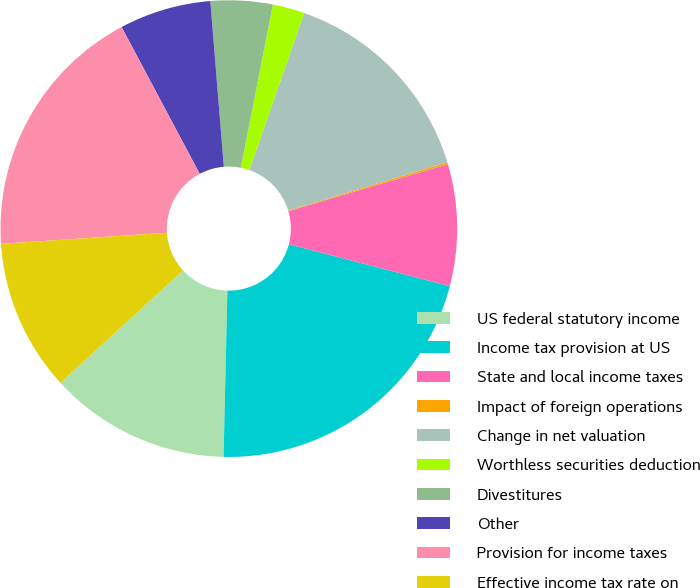Convert chart to OTSL. <chart><loc_0><loc_0><loc_500><loc_500><pie_chart><fcel>US federal statutory income<fcel>Income tax provision at US<fcel>State and local income taxes<fcel>Impact of foreign operations<fcel>Change in net valuation<fcel>Worthless securities deduction<fcel>Divestitures<fcel>Other<fcel>Provision for income taxes<fcel>Effective income tax rate on<nl><fcel>12.84%<fcel>21.31%<fcel>8.61%<fcel>0.14%<fcel>14.96%<fcel>2.26%<fcel>4.38%<fcel>6.49%<fcel>18.28%<fcel>10.73%<nl></chart> 